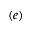<formula> <loc_0><loc_0><loc_500><loc_500>( e )</formula> 